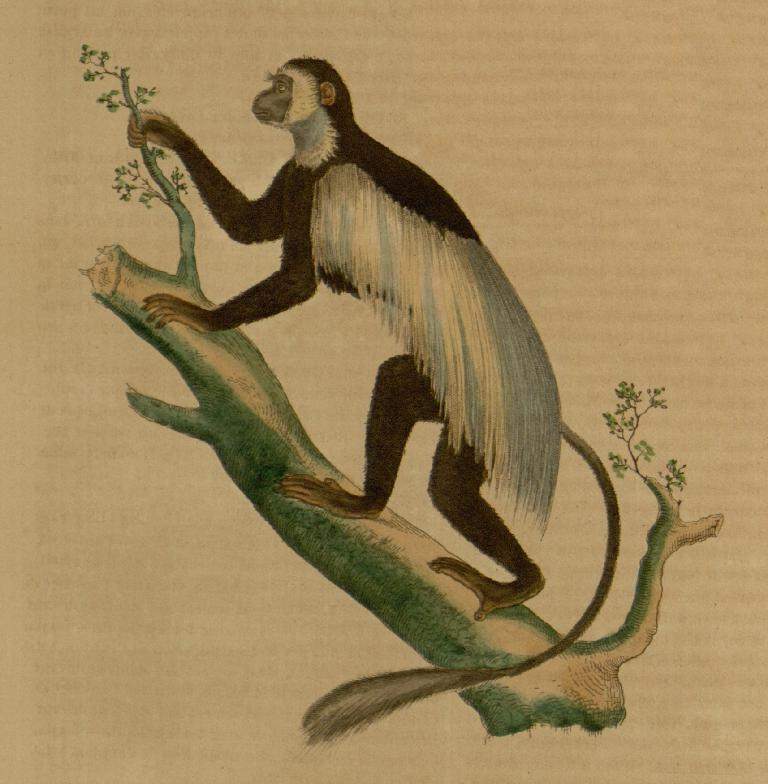What is the main subject of the image? There is a painting in the image. What is shown in the painting? The painting depicts an animal. Where is the animal located in the painting? The animal is on a branch. How many beads are scattered on the road in the image? There are no beads or roads present in the image; it features a painting of an animal on a branch. 